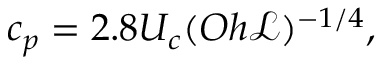<formula> <loc_0><loc_0><loc_500><loc_500>c _ { p } = 2 . 8 U _ { c } ( O h { \ m a t h s c r { L } } ) ^ { - 1 / 4 } ,</formula> 